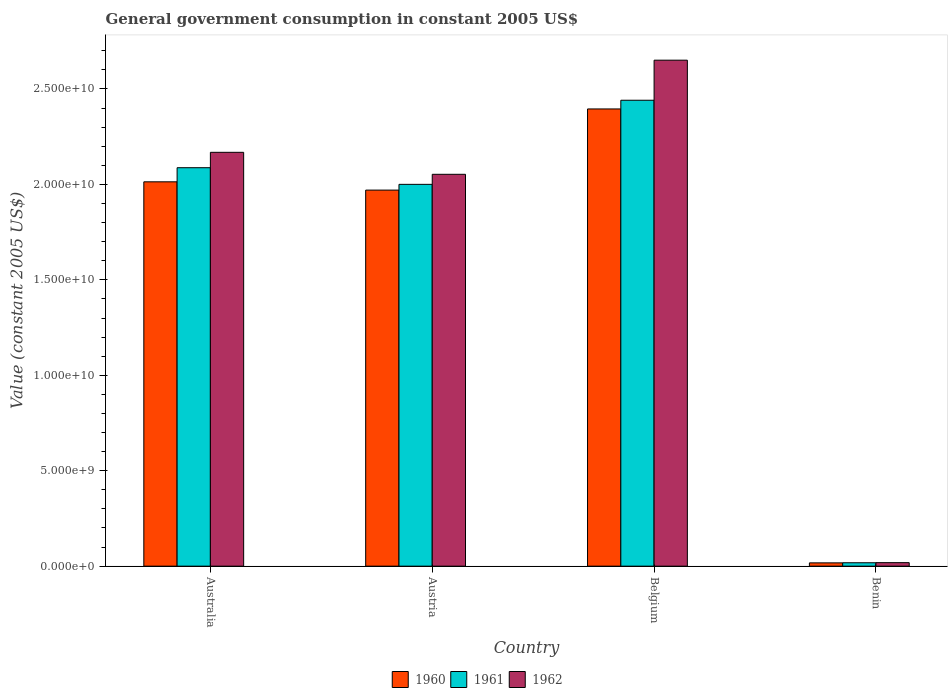Are the number of bars per tick equal to the number of legend labels?
Keep it short and to the point. Yes. How many bars are there on the 4th tick from the left?
Your answer should be compact. 3. How many bars are there on the 4th tick from the right?
Make the answer very short. 3. What is the label of the 2nd group of bars from the left?
Your answer should be compact. Austria. In how many cases, is the number of bars for a given country not equal to the number of legend labels?
Offer a very short reply. 0. What is the government conusmption in 1962 in Australia?
Ensure brevity in your answer.  2.17e+1. Across all countries, what is the maximum government conusmption in 1960?
Provide a succinct answer. 2.40e+1. Across all countries, what is the minimum government conusmption in 1960?
Give a very brief answer. 1.73e+08. In which country was the government conusmption in 1961 maximum?
Your answer should be very brief. Belgium. In which country was the government conusmption in 1962 minimum?
Offer a terse response. Benin. What is the total government conusmption in 1961 in the graph?
Provide a short and direct response. 6.55e+1. What is the difference between the government conusmption in 1962 in Austria and that in Belgium?
Make the answer very short. -5.98e+09. What is the difference between the government conusmption in 1960 in Austria and the government conusmption in 1961 in Benin?
Your answer should be very brief. 1.95e+1. What is the average government conusmption in 1962 per country?
Your answer should be compact. 1.72e+1. What is the difference between the government conusmption of/in 1962 and government conusmption of/in 1961 in Benin?
Ensure brevity in your answer.  5.64e+06. In how many countries, is the government conusmption in 1962 greater than 15000000000 US$?
Offer a terse response. 3. What is the ratio of the government conusmption in 1962 in Australia to that in Belgium?
Provide a short and direct response. 0.82. Is the government conusmption in 1961 in Australia less than that in Benin?
Give a very brief answer. No. What is the difference between the highest and the second highest government conusmption in 1961?
Offer a very short reply. -8.72e+08. What is the difference between the highest and the lowest government conusmption in 1960?
Your response must be concise. 2.38e+1. In how many countries, is the government conusmption in 1961 greater than the average government conusmption in 1961 taken over all countries?
Offer a terse response. 3. Is the sum of the government conusmption in 1960 in Australia and Belgium greater than the maximum government conusmption in 1961 across all countries?
Provide a succinct answer. Yes. How many bars are there?
Provide a short and direct response. 12. What is the difference between two consecutive major ticks on the Y-axis?
Your answer should be very brief. 5.00e+09. Are the values on the major ticks of Y-axis written in scientific E-notation?
Your answer should be very brief. Yes. Does the graph contain grids?
Your response must be concise. No. How many legend labels are there?
Provide a succinct answer. 3. What is the title of the graph?
Keep it short and to the point. General government consumption in constant 2005 US$. What is the label or title of the X-axis?
Offer a very short reply. Country. What is the label or title of the Y-axis?
Ensure brevity in your answer.  Value (constant 2005 US$). What is the Value (constant 2005 US$) in 1960 in Australia?
Make the answer very short. 2.01e+1. What is the Value (constant 2005 US$) in 1961 in Australia?
Your answer should be compact. 2.09e+1. What is the Value (constant 2005 US$) in 1962 in Australia?
Your answer should be compact. 2.17e+1. What is the Value (constant 2005 US$) in 1960 in Austria?
Your response must be concise. 1.97e+1. What is the Value (constant 2005 US$) of 1961 in Austria?
Your answer should be very brief. 2.00e+1. What is the Value (constant 2005 US$) in 1962 in Austria?
Keep it short and to the point. 2.05e+1. What is the Value (constant 2005 US$) in 1960 in Belgium?
Make the answer very short. 2.40e+1. What is the Value (constant 2005 US$) in 1961 in Belgium?
Offer a very short reply. 2.44e+1. What is the Value (constant 2005 US$) of 1962 in Belgium?
Provide a succinct answer. 2.65e+1. What is the Value (constant 2005 US$) of 1960 in Benin?
Offer a terse response. 1.73e+08. What is the Value (constant 2005 US$) in 1961 in Benin?
Your response must be concise. 1.79e+08. What is the Value (constant 2005 US$) in 1962 in Benin?
Ensure brevity in your answer.  1.85e+08. Across all countries, what is the maximum Value (constant 2005 US$) in 1960?
Ensure brevity in your answer.  2.40e+1. Across all countries, what is the maximum Value (constant 2005 US$) of 1961?
Offer a terse response. 2.44e+1. Across all countries, what is the maximum Value (constant 2005 US$) of 1962?
Give a very brief answer. 2.65e+1. Across all countries, what is the minimum Value (constant 2005 US$) of 1960?
Provide a succinct answer. 1.73e+08. Across all countries, what is the minimum Value (constant 2005 US$) of 1961?
Provide a short and direct response. 1.79e+08. Across all countries, what is the minimum Value (constant 2005 US$) of 1962?
Give a very brief answer. 1.85e+08. What is the total Value (constant 2005 US$) of 1960 in the graph?
Offer a terse response. 6.40e+1. What is the total Value (constant 2005 US$) in 1961 in the graph?
Give a very brief answer. 6.55e+1. What is the total Value (constant 2005 US$) of 1962 in the graph?
Give a very brief answer. 6.89e+1. What is the difference between the Value (constant 2005 US$) of 1960 in Australia and that in Austria?
Make the answer very short. 4.34e+08. What is the difference between the Value (constant 2005 US$) of 1961 in Australia and that in Austria?
Ensure brevity in your answer.  8.72e+08. What is the difference between the Value (constant 2005 US$) in 1962 in Australia and that in Austria?
Provide a succinct answer. 1.15e+09. What is the difference between the Value (constant 2005 US$) in 1960 in Australia and that in Belgium?
Provide a succinct answer. -3.82e+09. What is the difference between the Value (constant 2005 US$) of 1961 in Australia and that in Belgium?
Ensure brevity in your answer.  -3.53e+09. What is the difference between the Value (constant 2005 US$) in 1962 in Australia and that in Belgium?
Provide a succinct answer. -4.83e+09. What is the difference between the Value (constant 2005 US$) of 1960 in Australia and that in Benin?
Offer a terse response. 2.00e+1. What is the difference between the Value (constant 2005 US$) of 1961 in Australia and that in Benin?
Offer a very short reply. 2.07e+1. What is the difference between the Value (constant 2005 US$) of 1962 in Australia and that in Benin?
Offer a very short reply. 2.15e+1. What is the difference between the Value (constant 2005 US$) of 1960 in Austria and that in Belgium?
Your response must be concise. -4.25e+09. What is the difference between the Value (constant 2005 US$) in 1961 in Austria and that in Belgium?
Provide a succinct answer. -4.41e+09. What is the difference between the Value (constant 2005 US$) of 1962 in Austria and that in Belgium?
Your response must be concise. -5.98e+09. What is the difference between the Value (constant 2005 US$) of 1960 in Austria and that in Benin?
Make the answer very short. 1.95e+1. What is the difference between the Value (constant 2005 US$) in 1961 in Austria and that in Benin?
Your answer should be very brief. 1.98e+1. What is the difference between the Value (constant 2005 US$) of 1962 in Austria and that in Benin?
Your response must be concise. 2.03e+1. What is the difference between the Value (constant 2005 US$) in 1960 in Belgium and that in Benin?
Your answer should be compact. 2.38e+1. What is the difference between the Value (constant 2005 US$) in 1961 in Belgium and that in Benin?
Keep it short and to the point. 2.42e+1. What is the difference between the Value (constant 2005 US$) in 1962 in Belgium and that in Benin?
Your answer should be compact. 2.63e+1. What is the difference between the Value (constant 2005 US$) of 1960 in Australia and the Value (constant 2005 US$) of 1961 in Austria?
Keep it short and to the point. 1.33e+08. What is the difference between the Value (constant 2005 US$) of 1960 in Australia and the Value (constant 2005 US$) of 1962 in Austria?
Make the answer very short. -3.94e+08. What is the difference between the Value (constant 2005 US$) of 1961 in Australia and the Value (constant 2005 US$) of 1962 in Austria?
Offer a terse response. 3.45e+08. What is the difference between the Value (constant 2005 US$) of 1960 in Australia and the Value (constant 2005 US$) of 1961 in Belgium?
Offer a terse response. -4.27e+09. What is the difference between the Value (constant 2005 US$) of 1960 in Australia and the Value (constant 2005 US$) of 1962 in Belgium?
Your answer should be compact. -6.37e+09. What is the difference between the Value (constant 2005 US$) of 1961 in Australia and the Value (constant 2005 US$) of 1962 in Belgium?
Your answer should be very brief. -5.63e+09. What is the difference between the Value (constant 2005 US$) in 1960 in Australia and the Value (constant 2005 US$) in 1961 in Benin?
Your answer should be compact. 2.00e+1. What is the difference between the Value (constant 2005 US$) of 1960 in Australia and the Value (constant 2005 US$) of 1962 in Benin?
Keep it short and to the point. 2.00e+1. What is the difference between the Value (constant 2005 US$) of 1961 in Australia and the Value (constant 2005 US$) of 1962 in Benin?
Keep it short and to the point. 2.07e+1. What is the difference between the Value (constant 2005 US$) in 1960 in Austria and the Value (constant 2005 US$) in 1961 in Belgium?
Provide a succinct answer. -4.71e+09. What is the difference between the Value (constant 2005 US$) of 1960 in Austria and the Value (constant 2005 US$) of 1962 in Belgium?
Your response must be concise. -6.81e+09. What is the difference between the Value (constant 2005 US$) of 1961 in Austria and the Value (constant 2005 US$) of 1962 in Belgium?
Make the answer very short. -6.51e+09. What is the difference between the Value (constant 2005 US$) in 1960 in Austria and the Value (constant 2005 US$) in 1961 in Benin?
Make the answer very short. 1.95e+1. What is the difference between the Value (constant 2005 US$) in 1960 in Austria and the Value (constant 2005 US$) in 1962 in Benin?
Provide a short and direct response. 1.95e+1. What is the difference between the Value (constant 2005 US$) of 1961 in Austria and the Value (constant 2005 US$) of 1962 in Benin?
Your response must be concise. 1.98e+1. What is the difference between the Value (constant 2005 US$) of 1960 in Belgium and the Value (constant 2005 US$) of 1961 in Benin?
Your answer should be compact. 2.38e+1. What is the difference between the Value (constant 2005 US$) in 1960 in Belgium and the Value (constant 2005 US$) in 1962 in Benin?
Keep it short and to the point. 2.38e+1. What is the difference between the Value (constant 2005 US$) in 1961 in Belgium and the Value (constant 2005 US$) in 1962 in Benin?
Your answer should be compact. 2.42e+1. What is the average Value (constant 2005 US$) in 1960 per country?
Offer a terse response. 1.60e+1. What is the average Value (constant 2005 US$) in 1961 per country?
Keep it short and to the point. 1.64e+1. What is the average Value (constant 2005 US$) of 1962 per country?
Your response must be concise. 1.72e+1. What is the difference between the Value (constant 2005 US$) of 1960 and Value (constant 2005 US$) of 1961 in Australia?
Your response must be concise. -7.39e+08. What is the difference between the Value (constant 2005 US$) of 1960 and Value (constant 2005 US$) of 1962 in Australia?
Your answer should be compact. -1.55e+09. What is the difference between the Value (constant 2005 US$) in 1961 and Value (constant 2005 US$) in 1962 in Australia?
Your answer should be compact. -8.07e+08. What is the difference between the Value (constant 2005 US$) in 1960 and Value (constant 2005 US$) in 1961 in Austria?
Offer a terse response. -3.01e+08. What is the difference between the Value (constant 2005 US$) in 1960 and Value (constant 2005 US$) in 1962 in Austria?
Keep it short and to the point. -8.27e+08. What is the difference between the Value (constant 2005 US$) of 1961 and Value (constant 2005 US$) of 1962 in Austria?
Make the answer very short. -5.26e+08. What is the difference between the Value (constant 2005 US$) of 1960 and Value (constant 2005 US$) of 1961 in Belgium?
Offer a very short reply. -4.56e+08. What is the difference between the Value (constant 2005 US$) of 1960 and Value (constant 2005 US$) of 1962 in Belgium?
Offer a terse response. -2.55e+09. What is the difference between the Value (constant 2005 US$) in 1961 and Value (constant 2005 US$) in 1962 in Belgium?
Offer a terse response. -2.10e+09. What is the difference between the Value (constant 2005 US$) of 1960 and Value (constant 2005 US$) of 1961 in Benin?
Offer a very short reply. -5.64e+06. What is the difference between the Value (constant 2005 US$) of 1960 and Value (constant 2005 US$) of 1962 in Benin?
Your answer should be compact. -1.13e+07. What is the difference between the Value (constant 2005 US$) of 1961 and Value (constant 2005 US$) of 1962 in Benin?
Give a very brief answer. -5.64e+06. What is the ratio of the Value (constant 2005 US$) of 1961 in Australia to that in Austria?
Your answer should be very brief. 1.04. What is the ratio of the Value (constant 2005 US$) in 1962 in Australia to that in Austria?
Your answer should be very brief. 1.06. What is the ratio of the Value (constant 2005 US$) of 1960 in Australia to that in Belgium?
Your response must be concise. 0.84. What is the ratio of the Value (constant 2005 US$) of 1961 in Australia to that in Belgium?
Provide a succinct answer. 0.86. What is the ratio of the Value (constant 2005 US$) of 1962 in Australia to that in Belgium?
Ensure brevity in your answer.  0.82. What is the ratio of the Value (constant 2005 US$) in 1960 in Australia to that in Benin?
Make the answer very short. 116.16. What is the ratio of the Value (constant 2005 US$) of 1961 in Australia to that in Benin?
Give a very brief answer. 116.63. What is the ratio of the Value (constant 2005 US$) in 1962 in Australia to that in Benin?
Your response must be concise. 117.44. What is the ratio of the Value (constant 2005 US$) in 1960 in Austria to that in Belgium?
Ensure brevity in your answer.  0.82. What is the ratio of the Value (constant 2005 US$) in 1961 in Austria to that in Belgium?
Offer a terse response. 0.82. What is the ratio of the Value (constant 2005 US$) in 1962 in Austria to that in Belgium?
Your response must be concise. 0.77. What is the ratio of the Value (constant 2005 US$) in 1960 in Austria to that in Benin?
Offer a terse response. 113.66. What is the ratio of the Value (constant 2005 US$) of 1961 in Austria to that in Benin?
Make the answer very short. 111.76. What is the ratio of the Value (constant 2005 US$) of 1962 in Austria to that in Benin?
Keep it short and to the point. 111.2. What is the ratio of the Value (constant 2005 US$) in 1960 in Belgium to that in Benin?
Your response must be concise. 138.18. What is the ratio of the Value (constant 2005 US$) in 1961 in Belgium to that in Benin?
Provide a short and direct response. 136.38. What is the ratio of the Value (constant 2005 US$) in 1962 in Belgium to that in Benin?
Provide a short and direct response. 143.58. What is the difference between the highest and the second highest Value (constant 2005 US$) in 1960?
Ensure brevity in your answer.  3.82e+09. What is the difference between the highest and the second highest Value (constant 2005 US$) of 1961?
Provide a short and direct response. 3.53e+09. What is the difference between the highest and the second highest Value (constant 2005 US$) in 1962?
Offer a terse response. 4.83e+09. What is the difference between the highest and the lowest Value (constant 2005 US$) of 1960?
Ensure brevity in your answer.  2.38e+1. What is the difference between the highest and the lowest Value (constant 2005 US$) in 1961?
Your answer should be compact. 2.42e+1. What is the difference between the highest and the lowest Value (constant 2005 US$) of 1962?
Your answer should be very brief. 2.63e+1. 